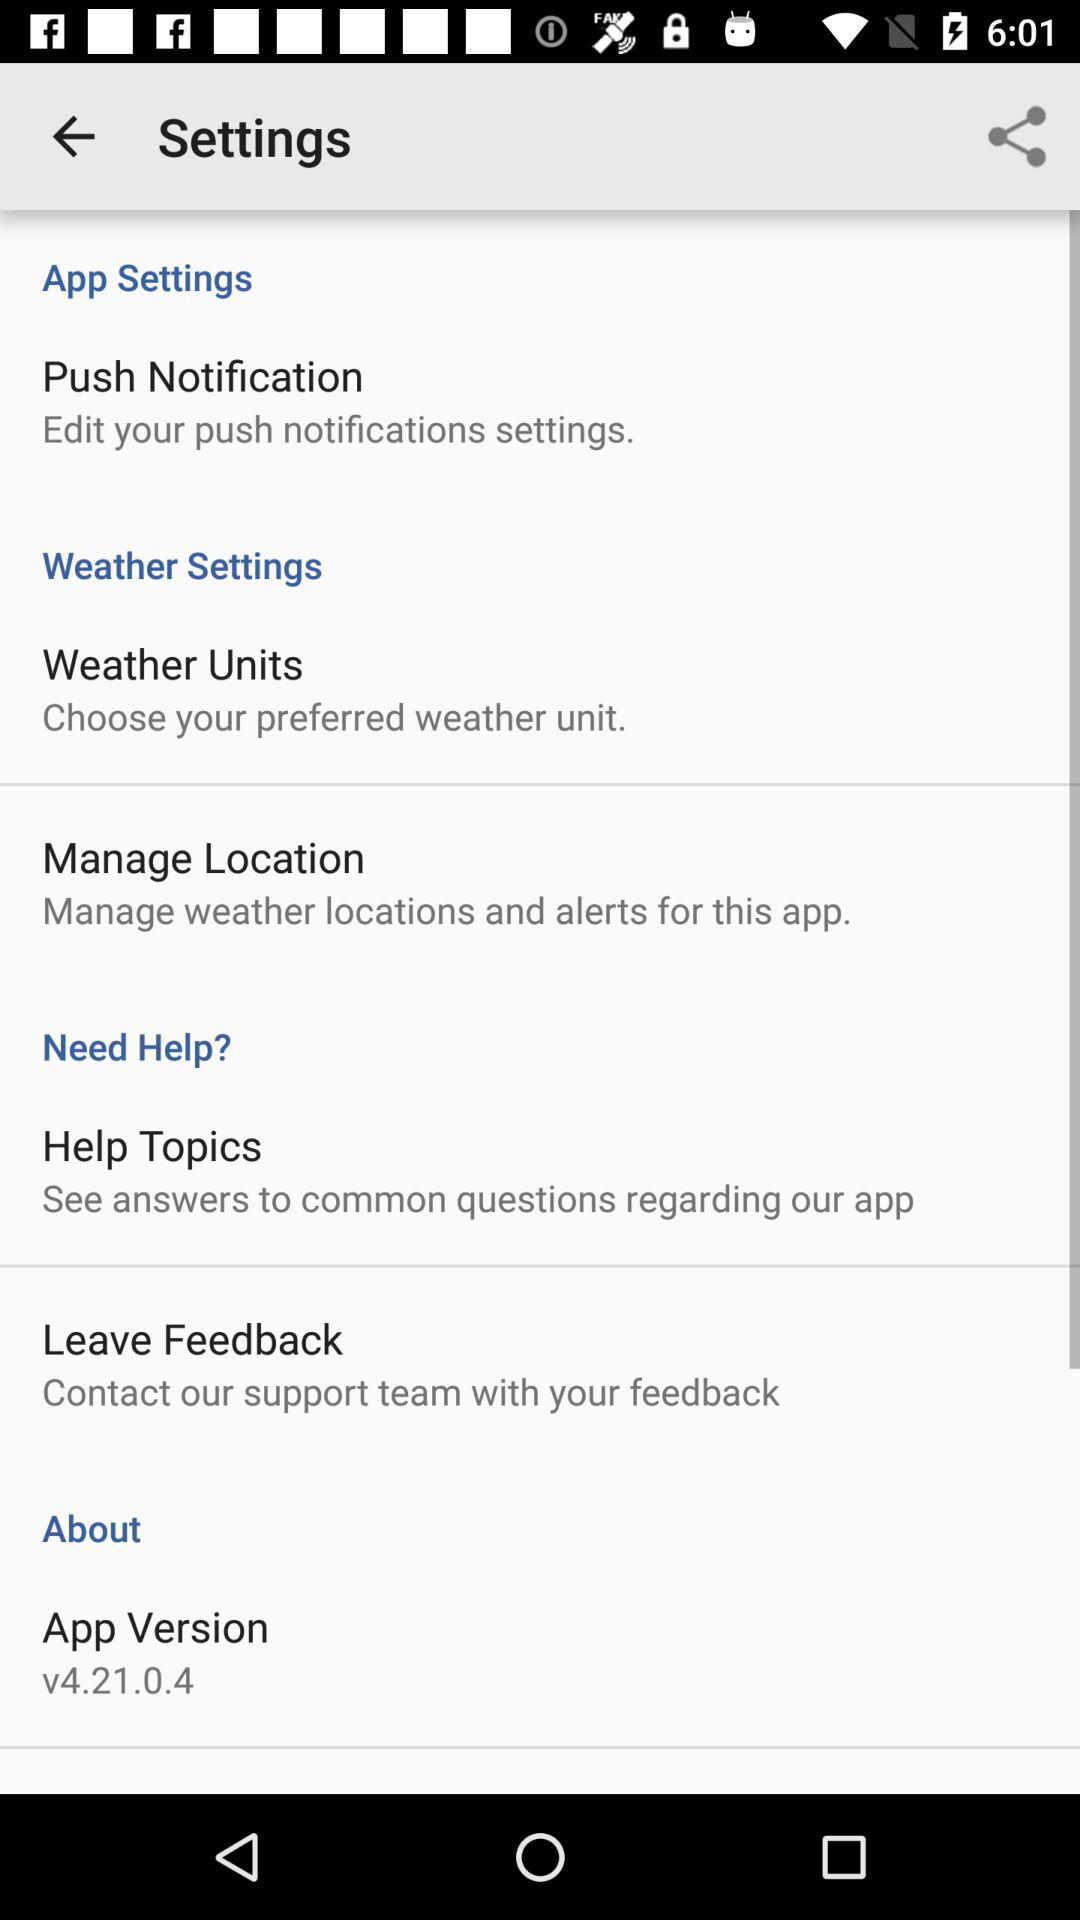What is the description of "Push Notification"? The description of "Push Notification" is "Edit your push notifications settings". 